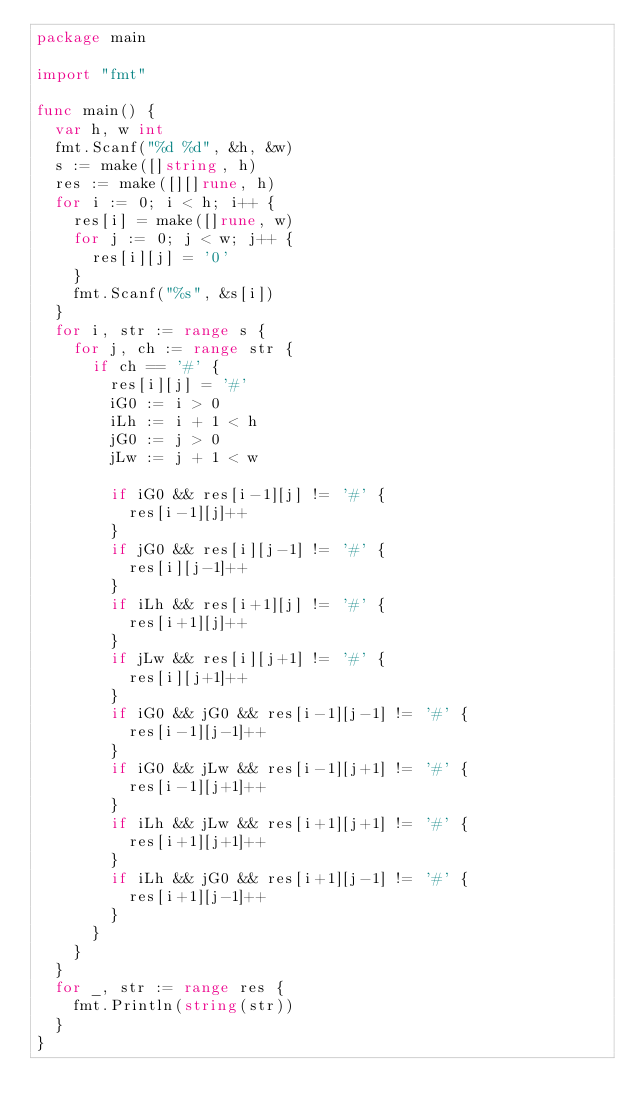<code> <loc_0><loc_0><loc_500><loc_500><_Go_>package main

import "fmt"

func main() {
	var h, w int
	fmt.Scanf("%d %d", &h, &w)
	s := make([]string, h)
	res := make([][]rune, h)
	for i := 0; i < h; i++ {
		res[i] = make([]rune, w)
		for j := 0; j < w; j++ {
			res[i][j] = '0'
		}
		fmt.Scanf("%s", &s[i])
	}
	for i, str := range s {
		for j, ch := range str {
			if ch == '#' {
				res[i][j] = '#'
				iG0 := i > 0
				iLh := i + 1 < h
				jG0 := j > 0
				jLw := j + 1 < w

				if iG0 && res[i-1][j] != '#' {
					res[i-1][j]++
				}
				if jG0 && res[i][j-1] != '#' {
					res[i][j-1]++
				}
				if iLh && res[i+1][j] != '#' {
					res[i+1][j]++
				}
				if jLw && res[i][j+1] != '#' {
					res[i][j+1]++
				}
				if iG0 && jG0 && res[i-1][j-1] != '#' {
					res[i-1][j-1]++
				}
				if iG0 && jLw && res[i-1][j+1] != '#' {
					res[i-1][j+1]++					
				}
				if iLh && jLw && res[i+1][j+1] != '#' {
					res[i+1][j+1]++
				}
				if iLh && jG0 && res[i+1][j-1] != '#' {
					res[i+1][j-1]++
				}
			}
		}
	}
	for _, str := range res {
		fmt.Println(string(str))
	}
}</code> 